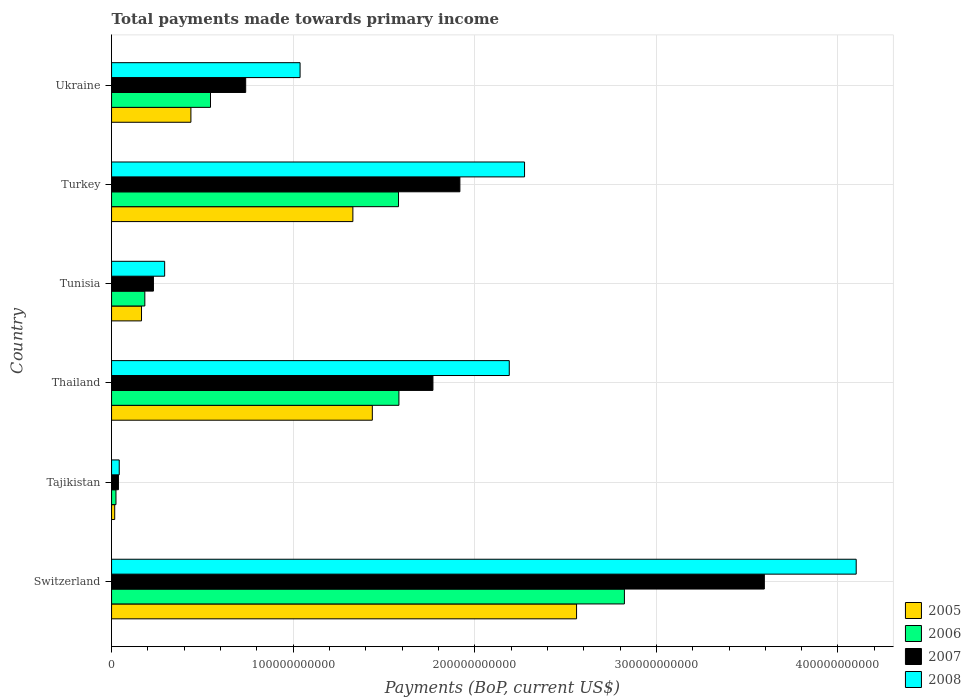How many groups of bars are there?
Offer a terse response. 6. Are the number of bars per tick equal to the number of legend labels?
Keep it short and to the point. Yes. How many bars are there on the 3rd tick from the top?
Provide a succinct answer. 4. What is the total payments made towards primary income in 2006 in Turkey?
Your answer should be very brief. 1.58e+11. Across all countries, what is the maximum total payments made towards primary income in 2005?
Your answer should be very brief. 2.56e+11. Across all countries, what is the minimum total payments made towards primary income in 2005?
Your response must be concise. 1.73e+09. In which country was the total payments made towards primary income in 2008 maximum?
Your answer should be very brief. Switzerland. In which country was the total payments made towards primary income in 2007 minimum?
Make the answer very short. Tajikistan. What is the total total payments made towards primary income in 2005 in the graph?
Make the answer very short. 5.94e+11. What is the difference between the total payments made towards primary income in 2008 in Tajikistan and that in Ukraine?
Your answer should be compact. -9.96e+1. What is the difference between the total payments made towards primary income in 2007 in Tunisia and the total payments made towards primary income in 2005 in Thailand?
Ensure brevity in your answer.  -1.21e+11. What is the average total payments made towards primary income in 2007 per country?
Ensure brevity in your answer.  1.38e+11. What is the difference between the total payments made towards primary income in 2006 and total payments made towards primary income in 2007 in Tunisia?
Your answer should be compact. -4.74e+09. In how many countries, is the total payments made towards primary income in 2006 greater than 360000000000 US$?
Give a very brief answer. 0. What is the ratio of the total payments made towards primary income in 2006 in Switzerland to that in Tajikistan?
Make the answer very short. 116.43. Is the total payments made towards primary income in 2008 in Switzerland less than that in Turkey?
Make the answer very short. No. Is the difference between the total payments made towards primary income in 2006 in Thailand and Turkey greater than the difference between the total payments made towards primary income in 2007 in Thailand and Turkey?
Provide a short and direct response. Yes. What is the difference between the highest and the second highest total payments made towards primary income in 2008?
Offer a very short reply. 1.83e+11. What is the difference between the highest and the lowest total payments made towards primary income in 2008?
Give a very brief answer. 4.06e+11. In how many countries, is the total payments made towards primary income in 2006 greater than the average total payments made towards primary income in 2006 taken over all countries?
Keep it short and to the point. 3. Is the sum of the total payments made towards primary income in 2005 in Tajikistan and Thailand greater than the maximum total payments made towards primary income in 2006 across all countries?
Provide a short and direct response. No. Is it the case that in every country, the sum of the total payments made towards primary income in 2006 and total payments made towards primary income in 2005 is greater than the sum of total payments made towards primary income in 2008 and total payments made towards primary income in 2007?
Your response must be concise. No. What does the 3rd bar from the bottom in Turkey represents?
Provide a short and direct response. 2007. How many countries are there in the graph?
Give a very brief answer. 6. What is the difference between two consecutive major ticks on the X-axis?
Keep it short and to the point. 1.00e+11. Does the graph contain any zero values?
Make the answer very short. No. Where does the legend appear in the graph?
Provide a short and direct response. Bottom right. How many legend labels are there?
Your answer should be compact. 4. How are the legend labels stacked?
Offer a very short reply. Vertical. What is the title of the graph?
Offer a very short reply. Total payments made towards primary income. What is the label or title of the X-axis?
Make the answer very short. Payments (BoP, current US$). What is the Payments (BoP, current US$) in 2005 in Switzerland?
Ensure brevity in your answer.  2.56e+11. What is the Payments (BoP, current US$) of 2006 in Switzerland?
Your response must be concise. 2.82e+11. What is the Payments (BoP, current US$) of 2007 in Switzerland?
Ensure brevity in your answer.  3.59e+11. What is the Payments (BoP, current US$) in 2008 in Switzerland?
Provide a short and direct response. 4.10e+11. What is the Payments (BoP, current US$) in 2005 in Tajikistan?
Offer a terse response. 1.73e+09. What is the Payments (BoP, current US$) in 2006 in Tajikistan?
Offer a terse response. 2.43e+09. What is the Payments (BoP, current US$) in 2007 in Tajikistan?
Your response must be concise. 3.78e+09. What is the Payments (BoP, current US$) of 2008 in Tajikistan?
Your answer should be very brief. 4.23e+09. What is the Payments (BoP, current US$) in 2005 in Thailand?
Give a very brief answer. 1.44e+11. What is the Payments (BoP, current US$) of 2006 in Thailand?
Make the answer very short. 1.58e+11. What is the Payments (BoP, current US$) in 2007 in Thailand?
Offer a very short reply. 1.77e+11. What is the Payments (BoP, current US$) in 2008 in Thailand?
Make the answer very short. 2.19e+11. What is the Payments (BoP, current US$) in 2005 in Tunisia?
Provide a short and direct response. 1.65e+1. What is the Payments (BoP, current US$) in 2006 in Tunisia?
Your answer should be compact. 1.83e+1. What is the Payments (BoP, current US$) of 2007 in Tunisia?
Offer a terse response. 2.31e+1. What is the Payments (BoP, current US$) in 2008 in Tunisia?
Your response must be concise. 2.92e+1. What is the Payments (BoP, current US$) in 2005 in Turkey?
Offer a very short reply. 1.33e+11. What is the Payments (BoP, current US$) in 2006 in Turkey?
Make the answer very short. 1.58e+11. What is the Payments (BoP, current US$) of 2007 in Turkey?
Your response must be concise. 1.92e+11. What is the Payments (BoP, current US$) of 2008 in Turkey?
Give a very brief answer. 2.27e+11. What is the Payments (BoP, current US$) of 2005 in Ukraine?
Your answer should be very brief. 4.37e+1. What is the Payments (BoP, current US$) of 2006 in Ukraine?
Offer a terse response. 5.45e+1. What is the Payments (BoP, current US$) in 2007 in Ukraine?
Give a very brief answer. 7.39e+1. What is the Payments (BoP, current US$) in 2008 in Ukraine?
Give a very brief answer. 1.04e+11. Across all countries, what is the maximum Payments (BoP, current US$) of 2005?
Provide a succinct answer. 2.56e+11. Across all countries, what is the maximum Payments (BoP, current US$) of 2006?
Your response must be concise. 2.82e+11. Across all countries, what is the maximum Payments (BoP, current US$) of 2007?
Offer a very short reply. 3.59e+11. Across all countries, what is the maximum Payments (BoP, current US$) in 2008?
Give a very brief answer. 4.10e+11. Across all countries, what is the minimum Payments (BoP, current US$) of 2005?
Ensure brevity in your answer.  1.73e+09. Across all countries, what is the minimum Payments (BoP, current US$) in 2006?
Ensure brevity in your answer.  2.43e+09. Across all countries, what is the minimum Payments (BoP, current US$) in 2007?
Provide a short and direct response. 3.78e+09. Across all countries, what is the minimum Payments (BoP, current US$) of 2008?
Make the answer very short. 4.23e+09. What is the total Payments (BoP, current US$) of 2005 in the graph?
Keep it short and to the point. 5.94e+11. What is the total Payments (BoP, current US$) in 2006 in the graph?
Give a very brief answer. 6.74e+11. What is the total Payments (BoP, current US$) in 2007 in the graph?
Your answer should be very brief. 8.29e+11. What is the total Payments (BoP, current US$) of 2008 in the graph?
Your answer should be compact. 9.94e+11. What is the difference between the Payments (BoP, current US$) of 2005 in Switzerland and that in Tajikistan?
Your answer should be very brief. 2.54e+11. What is the difference between the Payments (BoP, current US$) in 2006 in Switzerland and that in Tajikistan?
Make the answer very short. 2.80e+11. What is the difference between the Payments (BoP, current US$) of 2007 in Switzerland and that in Tajikistan?
Provide a short and direct response. 3.56e+11. What is the difference between the Payments (BoP, current US$) of 2008 in Switzerland and that in Tajikistan?
Provide a succinct answer. 4.06e+11. What is the difference between the Payments (BoP, current US$) of 2005 in Switzerland and that in Thailand?
Your answer should be very brief. 1.12e+11. What is the difference between the Payments (BoP, current US$) of 2006 in Switzerland and that in Thailand?
Keep it short and to the point. 1.24e+11. What is the difference between the Payments (BoP, current US$) of 2007 in Switzerland and that in Thailand?
Your answer should be compact. 1.82e+11. What is the difference between the Payments (BoP, current US$) in 2008 in Switzerland and that in Thailand?
Your answer should be very brief. 1.91e+11. What is the difference between the Payments (BoP, current US$) in 2005 in Switzerland and that in Tunisia?
Your answer should be very brief. 2.40e+11. What is the difference between the Payments (BoP, current US$) in 2006 in Switzerland and that in Tunisia?
Your response must be concise. 2.64e+11. What is the difference between the Payments (BoP, current US$) of 2007 in Switzerland and that in Tunisia?
Ensure brevity in your answer.  3.36e+11. What is the difference between the Payments (BoP, current US$) of 2008 in Switzerland and that in Tunisia?
Make the answer very short. 3.81e+11. What is the difference between the Payments (BoP, current US$) in 2005 in Switzerland and that in Turkey?
Ensure brevity in your answer.  1.23e+11. What is the difference between the Payments (BoP, current US$) in 2006 in Switzerland and that in Turkey?
Your response must be concise. 1.24e+11. What is the difference between the Payments (BoP, current US$) of 2007 in Switzerland and that in Turkey?
Give a very brief answer. 1.68e+11. What is the difference between the Payments (BoP, current US$) of 2008 in Switzerland and that in Turkey?
Offer a terse response. 1.83e+11. What is the difference between the Payments (BoP, current US$) in 2005 in Switzerland and that in Ukraine?
Ensure brevity in your answer.  2.12e+11. What is the difference between the Payments (BoP, current US$) in 2006 in Switzerland and that in Ukraine?
Ensure brevity in your answer.  2.28e+11. What is the difference between the Payments (BoP, current US$) of 2007 in Switzerland and that in Ukraine?
Offer a very short reply. 2.86e+11. What is the difference between the Payments (BoP, current US$) in 2008 in Switzerland and that in Ukraine?
Provide a succinct answer. 3.06e+11. What is the difference between the Payments (BoP, current US$) of 2005 in Tajikistan and that in Thailand?
Ensure brevity in your answer.  -1.42e+11. What is the difference between the Payments (BoP, current US$) in 2006 in Tajikistan and that in Thailand?
Give a very brief answer. -1.56e+11. What is the difference between the Payments (BoP, current US$) in 2007 in Tajikistan and that in Thailand?
Give a very brief answer. -1.73e+11. What is the difference between the Payments (BoP, current US$) in 2008 in Tajikistan and that in Thailand?
Give a very brief answer. -2.15e+11. What is the difference between the Payments (BoP, current US$) of 2005 in Tajikistan and that in Tunisia?
Your answer should be compact. -1.48e+1. What is the difference between the Payments (BoP, current US$) in 2006 in Tajikistan and that in Tunisia?
Offer a very short reply. -1.59e+1. What is the difference between the Payments (BoP, current US$) of 2007 in Tajikistan and that in Tunisia?
Keep it short and to the point. -1.93e+1. What is the difference between the Payments (BoP, current US$) of 2008 in Tajikistan and that in Tunisia?
Your answer should be compact. -2.50e+1. What is the difference between the Payments (BoP, current US$) in 2005 in Tajikistan and that in Turkey?
Ensure brevity in your answer.  -1.31e+11. What is the difference between the Payments (BoP, current US$) of 2006 in Tajikistan and that in Turkey?
Make the answer very short. -1.56e+11. What is the difference between the Payments (BoP, current US$) in 2007 in Tajikistan and that in Turkey?
Your answer should be compact. -1.88e+11. What is the difference between the Payments (BoP, current US$) in 2008 in Tajikistan and that in Turkey?
Offer a terse response. -2.23e+11. What is the difference between the Payments (BoP, current US$) of 2005 in Tajikistan and that in Ukraine?
Your response must be concise. -4.20e+1. What is the difference between the Payments (BoP, current US$) of 2006 in Tajikistan and that in Ukraine?
Your answer should be compact. -5.21e+1. What is the difference between the Payments (BoP, current US$) of 2007 in Tajikistan and that in Ukraine?
Provide a succinct answer. -7.01e+1. What is the difference between the Payments (BoP, current US$) of 2008 in Tajikistan and that in Ukraine?
Offer a terse response. -9.96e+1. What is the difference between the Payments (BoP, current US$) in 2005 in Thailand and that in Tunisia?
Keep it short and to the point. 1.27e+11. What is the difference between the Payments (BoP, current US$) of 2006 in Thailand and that in Tunisia?
Your answer should be compact. 1.40e+11. What is the difference between the Payments (BoP, current US$) of 2007 in Thailand and that in Tunisia?
Ensure brevity in your answer.  1.54e+11. What is the difference between the Payments (BoP, current US$) in 2008 in Thailand and that in Tunisia?
Offer a very short reply. 1.90e+11. What is the difference between the Payments (BoP, current US$) of 2005 in Thailand and that in Turkey?
Your response must be concise. 1.07e+1. What is the difference between the Payments (BoP, current US$) of 2006 in Thailand and that in Turkey?
Offer a terse response. 2.24e+08. What is the difference between the Payments (BoP, current US$) in 2007 in Thailand and that in Turkey?
Keep it short and to the point. -1.48e+1. What is the difference between the Payments (BoP, current US$) of 2008 in Thailand and that in Turkey?
Your response must be concise. -8.42e+09. What is the difference between the Payments (BoP, current US$) in 2005 in Thailand and that in Ukraine?
Your answer should be very brief. 9.99e+1. What is the difference between the Payments (BoP, current US$) in 2006 in Thailand and that in Ukraine?
Provide a short and direct response. 1.04e+11. What is the difference between the Payments (BoP, current US$) in 2007 in Thailand and that in Ukraine?
Offer a very short reply. 1.03e+11. What is the difference between the Payments (BoP, current US$) in 2008 in Thailand and that in Ukraine?
Your answer should be very brief. 1.15e+11. What is the difference between the Payments (BoP, current US$) in 2005 in Tunisia and that in Turkey?
Keep it short and to the point. -1.16e+11. What is the difference between the Payments (BoP, current US$) in 2006 in Tunisia and that in Turkey?
Provide a succinct answer. -1.40e+11. What is the difference between the Payments (BoP, current US$) in 2007 in Tunisia and that in Turkey?
Make the answer very short. -1.69e+11. What is the difference between the Payments (BoP, current US$) of 2008 in Tunisia and that in Turkey?
Provide a short and direct response. -1.98e+11. What is the difference between the Payments (BoP, current US$) of 2005 in Tunisia and that in Ukraine?
Ensure brevity in your answer.  -2.72e+1. What is the difference between the Payments (BoP, current US$) in 2006 in Tunisia and that in Ukraine?
Your answer should be very brief. -3.62e+1. What is the difference between the Payments (BoP, current US$) of 2007 in Tunisia and that in Ukraine?
Offer a very short reply. -5.08e+1. What is the difference between the Payments (BoP, current US$) of 2008 in Tunisia and that in Ukraine?
Offer a very short reply. -7.46e+1. What is the difference between the Payments (BoP, current US$) of 2005 in Turkey and that in Ukraine?
Provide a short and direct response. 8.92e+1. What is the difference between the Payments (BoP, current US$) of 2006 in Turkey and that in Ukraine?
Your answer should be compact. 1.04e+11. What is the difference between the Payments (BoP, current US$) in 2007 in Turkey and that in Ukraine?
Your response must be concise. 1.18e+11. What is the difference between the Payments (BoP, current US$) in 2008 in Turkey and that in Ukraine?
Give a very brief answer. 1.24e+11. What is the difference between the Payments (BoP, current US$) in 2005 in Switzerland and the Payments (BoP, current US$) in 2006 in Tajikistan?
Your answer should be compact. 2.54e+11. What is the difference between the Payments (BoP, current US$) of 2005 in Switzerland and the Payments (BoP, current US$) of 2007 in Tajikistan?
Your response must be concise. 2.52e+11. What is the difference between the Payments (BoP, current US$) in 2005 in Switzerland and the Payments (BoP, current US$) in 2008 in Tajikistan?
Provide a succinct answer. 2.52e+11. What is the difference between the Payments (BoP, current US$) of 2006 in Switzerland and the Payments (BoP, current US$) of 2007 in Tajikistan?
Your response must be concise. 2.79e+11. What is the difference between the Payments (BoP, current US$) of 2006 in Switzerland and the Payments (BoP, current US$) of 2008 in Tajikistan?
Keep it short and to the point. 2.78e+11. What is the difference between the Payments (BoP, current US$) in 2007 in Switzerland and the Payments (BoP, current US$) in 2008 in Tajikistan?
Your answer should be compact. 3.55e+11. What is the difference between the Payments (BoP, current US$) in 2005 in Switzerland and the Payments (BoP, current US$) in 2006 in Thailand?
Keep it short and to the point. 9.78e+1. What is the difference between the Payments (BoP, current US$) in 2005 in Switzerland and the Payments (BoP, current US$) in 2007 in Thailand?
Offer a very short reply. 7.91e+1. What is the difference between the Payments (BoP, current US$) in 2005 in Switzerland and the Payments (BoP, current US$) in 2008 in Thailand?
Provide a succinct answer. 3.71e+1. What is the difference between the Payments (BoP, current US$) in 2006 in Switzerland and the Payments (BoP, current US$) in 2007 in Thailand?
Offer a terse response. 1.05e+11. What is the difference between the Payments (BoP, current US$) of 2006 in Switzerland and the Payments (BoP, current US$) of 2008 in Thailand?
Ensure brevity in your answer.  6.34e+1. What is the difference between the Payments (BoP, current US$) in 2007 in Switzerland and the Payments (BoP, current US$) in 2008 in Thailand?
Ensure brevity in your answer.  1.40e+11. What is the difference between the Payments (BoP, current US$) of 2005 in Switzerland and the Payments (BoP, current US$) of 2006 in Tunisia?
Keep it short and to the point. 2.38e+11. What is the difference between the Payments (BoP, current US$) in 2005 in Switzerland and the Payments (BoP, current US$) in 2007 in Tunisia?
Make the answer very short. 2.33e+11. What is the difference between the Payments (BoP, current US$) of 2005 in Switzerland and the Payments (BoP, current US$) of 2008 in Tunisia?
Ensure brevity in your answer.  2.27e+11. What is the difference between the Payments (BoP, current US$) in 2006 in Switzerland and the Payments (BoP, current US$) in 2007 in Tunisia?
Keep it short and to the point. 2.59e+11. What is the difference between the Payments (BoP, current US$) in 2006 in Switzerland and the Payments (BoP, current US$) in 2008 in Tunisia?
Offer a terse response. 2.53e+11. What is the difference between the Payments (BoP, current US$) of 2007 in Switzerland and the Payments (BoP, current US$) of 2008 in Tunisia?
Your answer should be very brief. 3.30e+11. What is the difference between the Payments (BoP, current US$) of 2005 in Switzerland and the Payments (BoP, current US$) of 2006 in Turkey?
Keep it short and to the point. 9.80e+1. What is the difference between the Payments (BoP, current US$) of 2005 in Switzerland and the Payments (BoP, current US$) of 2007 in Turkey?
Make the answer very short. 6.42e+1. What is the difference between the Payments (BoP, current US$) of 2005 in Switzerland and the Payments (BoP, current US$) of 2008 in Turkey?
Your answer should be very brief. 2.86e+1. What is the difference between the Payments (BoP, current US$) in 2006 in Switzerland and the Payments (BoP, current US$) in 2007 in Turkey?
Offer a terse response. 9.06e+1. What is the difference between the Payments (BoP, current US$) in 2006 in Switzerland and the Payments (BoP, current US$) in 2008 in Turkey?
Your answer should be very brief. 5.50e+1. What is the difference between the Payments (BoP, current US$) of 2007 in Switzerland and the Payments (BoP, current US$) of 2008 in Turkey?
Your answer should be very brief. 1.32e+11. What is the difference between the Payments (BoP, current US$) in 2005 in Switzerland and the Payments (BoP, current US$) in 2006 in Ukraine?
Provide a succinct answer. 2.02e+11. What is the difference between the Payments (BoP, current US$) in 2005 in Switzerland and the Payments (BoP, current US$) in 2007 in Ukraine?
Provide a succinct answer. 1.82e+11. What is the difference between the Payments (BoP, current US$) in 2005 in Switzerland and the Payments (BoP, current US$) in 2008 in Ukraine?
Your response must be concise. 1.52e+11. What is the difference between the Payments (BoP, current US$) in 2006 in Switzerland and the Payments (BoP, current US$) in 2007 in Ukraine?
Give a very brief answer. 2.09e+11. What is the difference between the Payments (BoP, current US$) in 2006 in Switzerland and the Payments (BoP, current US$) in 2008 in Ukraine?
Give a very brief answer. 1.79e+11. What is the difference between the Payments (BoP, current US$) in 2007 in Switzerland and the Payments (BoP, current US$) in 2008 in Ukraine?
Give a very brief answer. 2.56e+11. What is the difference between the Payments (BoP, current US$) in 2005 in Tajikistan and the Payments (BoP, current US$) in 2006 in Thailand?
Provide a succinct answer. -1.57e+11. What is the difference between the Payments (BoP, current US$) in 2005 in Tajikistan and the Payments (BoP, current US$) in 2007 in Thailand?
Your answer should be very brief. -1.75e+11. What is the difference between the Payments (BoP, current US$) in 2005 in Tajikistan and the Payments (BoP, current US$) in 2008 in Thailand?
Offer a very short reply. -2.17e+11. What is the difference between the Payments (BoP, current US$) of 2006 in Tajikistan and the Payments (BoP, current US$) of 2007 in Thailand?
Provide a succinct answer. -1.75e+11. What is the difference between the Payments (BoP, current US$) in 2006 in Tajikistan and the Payments (BoP, current US$) in 2008 in Thailand?
Offer a terse response. -2.17e+11. What is the difference between the Payments (BoP, current US$) in 2007 in Tajikistan and the Payments (BoP, current US$) in 2008 in Thailand?
Offer a terse response. -2.15e+11. What is the difference between the Payments (BoP, current US$) in 2005 in Tajikistan and the Payments (BoP, current US$) in 2006 in Tunisia?
Make the answer very short. -1.66e+1. What is the difference between the Payments (BoP, current US$) in 2005 in Tajikistan and the Payments (BoP, current US$) in 2007 in Tunisia?
Offer a terse response. -2.13e+1. What is the difference between the Payments (BoP, current US$) of 2005 in Tajikistan and the Payments (BoP, current US$) of 2008 in Tunisia?
Offer a terse response. -2.75e+1. What is the difference between the Payments (BoP, current US$) of 2006 in Tajikistan and the Payments (BoP, current US$) of 2007 in Tunisia?
Offer a terse response. -2.06e+1. What is the difference between the Payments (BoP, current US$) of 2006 in Tajikistan and the Payments (BoP, current US$) of 2008 in Tunisia?
Provide a short and direct response. -2.68e+1. What is the difference between the Payments (BoP, current US$) in 2007 in Tajikistan and the Payments (BoP, current US$) in 2008 in Tunisia?
Your response must be concise. -2.55e+1. What is the difference between the Payments (BoP, current US$) in 2005 in Tajikistan and the Payments (BoP, current US$) in 2006 in Turkey?
Provide a succinct answer. -1.56e+11. What is the difference between the Payments (BoP, current US$) of 2005 in Tajikistan and the Payments (BoP, current US$) of 2007 in Turkey?
Your response must be concise. -1.90e+11. What is the difference between the Payments (BoP, current US$) in 2005 in Tajikistan and the Payments (BoP, current US$) in 2008 in Turkey?
Your response must be concise. -2.26e+11. What is the difference between the Payments (BoP, current US$) of 2006 in Tajikistan and the Payments (BoP, current US$) of 2007 in Turkey?
Make the answer very short. -1.89e+11. What is the difference between the Payments (BoP, current US$) of 2006 in Tajikistan and the Payments (BoP, current US$) of 2008 in Turkey?
Offer a terse response. -2.25e+11. What is the difference between the Payments (BoP, current US$) in 2007 in Tajikistan and the Payments (BoP, current US$) in 2008 in Turkey?
Keep it short and to the point. -2.24e+11. What is the difference between the Payments (BoP, current US$) in 2005 in Tajikistan and the Payments (BoP, current US$) in 2006 in Ukraine?
Your answer should be compact. -5.27e+1. What is the difference between the Payments (BoP, current US$) of 2005 in Tajikistan and the Payments (BoP, current US$) of 2007 in Ukraine?
Your answer should be very brief. -7.21e+1. What is the difference between the Payments (BoP, current US$) in 2005 in Tajikistan and the Payments (BoP, current US$) in 2008 in Ukraine?
Keep it short and to the point. -1.02e+11. What is the difference between the Payments (BoP, current US$) in 2006 in Tajikistan and the Payments (BoP, current US$) in 2007 in Ukraine?
Ensure brevity in your answer.  -7.14e+1. What is the difference between the Payments (BoP, current US$) of 2006 in Tajikistan and the Payments (BoP, current US$) of 2008 in Ukraine?
Provide a succinct answer. -1.01e+11. What is the difference between the Payments (BoP, current US$) of 2007 in Tajikistan and the Payments (BoP, current US$) of 2008 in Ukraine?
Provide a short and direct response. -1.00e+11. What is the difference between the Payments (BoP, current US$) of 2005 in Thailand and the Payments (BoP, current US$) of 2006 in Tunisia?
Your answer should be very brief. 1.25e+11. What is the difference between the Payments (BoP, current US$) of 2005 in Thailand and the Payments (BoP, current US$) of 2007 in Tunisia?
Make the answer very short. 1.21e+11. What is the difference between the Payments (BoP, current US$) of 2005 in Thailand and the Payments (BoP, current US$) of 2008 in Tunisia?
Keep it short and to the point. 1.14e+11. What is the difference between the Payments (BoP, current US$) of 2006 in Thailand and the Payments (BoP, current US$) of 2007 in Tunisia?
Offer a terse response. 1.35e+11. What is the difference between the Payments (BoP, current US$) of 2006 in Thailand and the Payments (BoP, current US$) of 2008 in Tunisia?
Your answer should be compact. 1.29e+11. What is the difference between the Payments (BoP, current US$) of 2007 in Thailand and the Payments (BoP, current US$) of 2008 in Tunisia?
Give a very brief answer. 1.48e+11. What is the difference between the Payments (BoP, current US$) of 2005 in Thailand and the Payments (BoP, current US$) of 2006 in Turkey?
Offer a terse response. -1.44e+1. What is the difference between the Payments (BoP, current US$) in 2005 in Thailand and the Payments (BoP, current US$) in 2007 in Turkey?
Provide a succinct answer. -4.82e+1. What is the difference between the Payments (BoP, current US$) of 2005 in Thailand and the Payments (BoP, current US$) of 2008 in Turkey?
Give a very brief answer. -8.38e+1. What is the difference between the Payments (BoP, current US$) of 2006 in Thailand and the Payments (BoP, current US$) of 2007 in Turkey?
Provide a short and direct response. -3.36e+1. What is the difference between the Payments (BoP, current US$) in 2006 in Thailand and the Payments (BoP, current US$) in 2008 in Turkey?
Provide a short and direct response. -6.92e+1. What is the difference between the Payments (BoP, current US$) of 2007 in Thailand and the Payments (BoP, current US$) of 2008 in Turkey?
Give a very brief answer. -5.04e+1. What is the difference between the Payments (BoP, current US$) in 2005 in Thailand and the Payments (BoP, current US$) in 2006 in Ukraine?
Provide a short and direct response. 8.91e+1. What is the difference between the Payments (BoP, current US$) in 2005 in Thailand and the Payments (BoP, current US$) in 2007 in Ukraine?
Provide a succinct answer. 6.97e+1. What is the difference between the Payments (BoP, current US$) in 2005 in Thailand and the Payments (BoP, current US$) in 2008 in Ukraine?
Ensure brevity in your answer.  3.98e+1. What is the difference between the Payments (BoP, current US$) of 2006 in Thailand and the Payments (BoP, current US$) of 2007 in Ukraine?
Offer a terse response. 8.44e+1. What is the difference between the Payments (BoP, current US$) in 2006 in Thailand and the Payments (BoP, current US$) in 2008 in Ukraine?
Your answer should be very brief. 5.44e+1. What is the difference between the Payments (BoP, current US$) of 2007 in Thailand and the Payments (BoP, current US$) of 2008 in Ukraine?
Keep it short and to the point. 7.32e+1. What is the difference between the Payments (BoP, current US$) in 2005 in Tunisia and the Payments (BoP, current US$) in 2006 in Turkey?
Provide a short and direct response. -1.42e+11. What is the difference between the Payments (BoP, current US$) in 2005 in Tunisia and the Payments (BoP, current US$) in 2007 in Turkey?
Offer a terse response. -1.75e+11. What is the difference between the Payments (BoP, current US$) of 2005 in Tunisia and the Payments (BoP, current US$) of 2008 in Turkey?
Offer a very short reply. -2.11e+11. What is the difference between the Payments (BoP, current US$) in 2006 in Tunisia and the Payments (BoP, current US$) in 2007 in Turkey?
Make the answer very short. -1.73e+11. What is the difference between the Payments (BoP, current US$) in 2006 in Tunisia and the Payments (BoP, current US$) in 2008 in Turkey?
Your answer should be very brief. -2.09e+11. What is the difference between the Payments (BoP, current US$) of 2007 in Tunisia and the Payments (BoP, current US$) of 2008 in Turkey?
Offer a very short reply. -2.04e+11. What is the difference between the Payments (BoP, current US$) in 2005 in Tunisia and the Payments (BoP, current US$) in 2006 in Ukraine?
Give a very brief answer. -3.80e+1. What is the difference between the Payments (BoP, current US$) of 2005 in Tunisia and the Payments (BoP, current US$) of 2007 in Ukraine?
Provide a short and direct response. -5.74e+1. What is the difference between the Payments (BoP, current US$) of 2005 in Tunisia and the Payments (BoP, current US$) of 2008 in Ukraine?
Your answer should be very brief. -8.73e+1. What is the difference between the Payments (BoP, current US$) of 2006 in Tunisia and the Payments (BoP, current US$) of 2007 in Ukraine?
Ensure brevity in your answer.  -5.55e+1. What is the difference between the Payments (BoP, current US$) of 2006 in Tunisia and the Payments (BoP, current US$) of 2008 in Ukraine?
Keep it short and to the point. -8.55e+1. What is the difference between the Payments (BoP, current US$) of 2007 in Tunisia and the Payments (BoP, current US$) of 2008 in Ukraine?
Ensure brevity in your answer.  -8.07e+1. What is the difference between the Payments (BoP, current US$) of 2005 in Turkey and the Payments (BoP, current US$) of 2006 in Ukraine?
Ensure brevity in your answer.  7.84e+1. What is the difference between the Payments (BoP, current US$) of 2005 in Turkey and the Payments (BoP, current US$) of 2007 in Ukraine?
Give a very brief answer. 5.90e+1. What is the difference between the Payments (BoP, current US$) of 2005 in Turkey and the Payments (BoP, current US$) of 2008 in Ukraine?
Make the answer very short. 2.91e+1. What is the difference between the Payments (BoP, current US$) of 2006 in Turkey and the Payments (BoP, current US$) of 2007 in Ukraine?
Give a very brief answer. 8.42e+1. What is the difference between the Payments (BoP, current US$) in 2006 in Turkey and the Payments (BoP, current US$) in 2008 in Ukraine?
Offer a very short reply. 5.42e+1. What is the difference between the Payments (BoP, current US$) of 2007 in Turkey and the Payments (BoP, current US$) of 2008 in Ukraine?
Offer a very short reply. 8.80e+1. What is the average Payments (BoP, current US$) in 2005 per country?
Your answer should be very brief. 9.91e+1. What is the average Payments (BoP, current US$) of 2006 per country?
Your answer should be very brief. 1.12e+11. What is the average Payments (BoP, current US$) of 2007 per country?
Keep it short and to the point. 1.38e+11. What is the average Payments (BoP, current US$) in 2008 per country?
Keep it short and to the point. 1.66e+11. What is the difference between the Payments (BoP, current US$) in 2005 and Payments (BoP, current US$) in 2006 in Switzerland?
Your answer should be very brief. -2.63e+1. What is the difference between the Payments (BoP, current US$) of 2005 and Payments (BoP, current US$) of 2007 in Switzerland?
Your answer should be very brief. -1.03e+11. What is the difference between the Payments (BoP, current US$) of 2005 and Payments (BoP, current US$) of 2008 in Switzerland?
Your response must be concise. -1.54e+11. What is the difference between the Payments (BoP, current US$) in 2006 and Payments (BoP, current US$) in 2007 in Switzerland?
Your answer should be very brief. -7.71e+1. What is the difference between the Payments (BoP, current US$) of 2006 and Payments (BoP, current US$) of 2008 in Switzerland?
Your answer should be very brief. -1.28e+11. What is the difference between the Payments (BoP, current US$) of 2007 and Payments (BoP, current US$) of 2008 in Switzerland?
Your answer should be very brief. -5.06e+1. What is the difference between the Payments (BoP, current US$) of 2005 and Payments (BoP, current US$) of 2006 in Tajikistan?
Your answer should be compact. -6.93e+08. What is the difference between the Payments (BoP, current US$) in 2005 and Payments (BoP, current US$) in 2007 in Tajikistan?
Offer a terse response. -2.05e+09. What is the difference between the Payments (BoP, current US$) in 2005 and Payments (BoP, current US$) in 2008 in Tajikistan?
Make the answer very short. -2.49e+09. What is the difference between the Payments (BoP, current US$) in 2006 and Payments (BoP, current US$) in 2007 in Tajikistan?
Give a very brief answer. -1.35e+09. What is the difference between the Payments (BoP, current US$) in 2006 and Payments (BoP, current US$) in 2008 in Tajikistan?
Your answer should be very brief. -1.80e+09. What is the difference between the Payments (BoP, current US$) of 2007 and Payments (BoP, current US$) of 2008 in Tajikistan?
Offer a terse response. -4.47e+08. What is the difference between the Payments (BoP, current US$) of 2005 and Payments (BoP, current US$) of 2006 in Thailand?
Provide a short and direct response. -1.46e+1. What is the difference between the Payments (BoP, current US$) in 2005 and Payments (BoP, current US$) in 2007 in Thailand?
Your answer should be very brief. -3.34e+1. What is the difference between the Payments (BoP, current US$) of 2005 and Payments (BoP, current US$) of 2008 in Thailand?
Your answer should be very brief. -7.54e+1. What is the difference between the Payments (BoP, current US$) in 2006 and Payments (BoP, current US$) in 2007 in Thailand?
Your answer should be very brief. -1.87e+1. What is the difference between the Payments (BoP, current US$) in 2006 and Payments (BoP, current US$) in 2008 in Thailand?
Ensure brevity in your answer.  -6.08e+1. What is the difference between the Payments (BoP, current US$) in 2007 and Payments (BoP, current US$) in 2008 in Thailand?
Your response must be concise. -4.20e+1. What is the difference between the Payments (BoP, current US$) of 2005 and Payments (BoP, current US$) of 2006 in Tunisia?
Give a very brief answer. -1.82e+09. What is the difference between the Payments (BoP, current US$) of 2005 and Payments (BoP, current US$) of 2007 in Tunisia?
Make the answer very short. -6.57e+09. What is the difference between the Payments (BoP, current US$) of 2005 and Payments (BoP, current US$) of 2008 in Tunisia?
Offer a very short reply. -1.27e+1. What is the difference between the Payments (BoP, current US$) in 2006 and Payments (BoP, current US$) in 2007 in Tunisia?
Give a very brief answer. -4.74e+09. What is the difference between the Payments (BoP, current US$) of 2006 and Payments (BoP, current US$) of 2008 in Tunisia?
Provide a succinct answer. -1.09e+1. What is the difference between the Payments (BoP, current US$) in 2007 and Payments (BoP, current US$) in 2008 in Tunisia?
Provide a succinct answer. -6.17e+09. What is the difference between the Payments (BoP, current US$) in 2005 and Payments (BoP, current US$) in 2006 in Turkey?
Your response must be concise. -2.51e+1. What is the difference between the Payments (BoP, current US$) in 2005 and Payments (BoP, current US$) in 2007 in Turkey?
Make the answer very short. -5.89e+1. What is the difference between the Payments (BoP, current US$) in 2005 and Payments (BoP, current US$) in 2008 in Turkey?
Keep it short and to the point. -9.45e+1. What is the difference between the Payments (BoP, current US$) in 2006 and Payments (BoP, current US$) in 2007 in Turkey?
Provide a succinct answer. -3.38e+1. What is the difference between the Payments (BoP, current US$) in 2006 and Payments (BoP, current US$) in 2008 in Turkey?
Your answer should be very brief. -6.94e+1. What is the difference between the Payments (BoP, current US$) in 2007 and Payments (BoP, current US$) in 2008 in Turkey?
Keep it short and to the point. -3.56e+1. What is the difference between the Payments (BoP, current US$) in 2005 and Payments (BoP, current US$) in 2006 in Ukraine?
Keep it short and to the point. -1.08e+1. What is the difference between the Payments (BoP, current US$) in 2005 and Payments (BoP, current US$) in 2007 in Ukraine?
Your response must be concise. -3.02e+1. What is the difference between the Payments (BoP, current US$) in 2005 and Payments (BoP, current US$) in 2008 in Ukraine?
Your answer should be compact. -6.01e+1. What is the difference between the Payments (BoP, current US$) of 2006 and Payments (BoP, current US$) of 2007 in Ukraine?
Offer a very short reply. -1.94e+1. What is the difference between the Payments (BoP, current US$) in 2006 and Payments (BoP, current US$) in 2008 in Ukraine?
Your response must be concise. -4.93e+1. What is the difference between the Payments (BoP, current US$) of 2007 and Payments (BoP, current US$) of 2008 in Ukraine?
Provide a succinct answer. -2.99e+1. What is the ratio of the Payments (BoP, current US$) of 2005 in Switzerland to that in Tajikistan?
Keep it short and to the point. 147.77. What is the ratio of the Payments (BoP, current US$) in 2006 in Switzerland to that in Tajikistan?
Your answer should be compact. 116.43. What is the ratio of the Payments (BoP, current US$) of 2007 in Switzerland to that in Tajikistan?
Your response must be concise. 95.09. What is the ratio of the Payments (BoP, current US$) in 2008 in Switzerland to that in Tajikistan?
Ensure brevity in your answer.  97. What is the ratio of the Payments (BoP, current US$) in 2005 in Switzerland to that in Thailand?
Ensure brevity in your answer.  1.78. What is the ratio of the Payments (BoP, current US$) of 2006 in Switzerland to that in Thailand?
Ensure brevity in your answer.  1.78. What is the ratio of the Payments (BoP, current US$) of 2007 in Switzerland to that in Thailand?
Your answer should be compact. 2.03. What is the ratio of the Payments (BoP, current US$) of 2008 in Switzerland to that in Thailand?
Ensure brevity in your answer.  1.87. What is the ratio of the Payments (BoP, current US$) of 2005 in Switzerland to that in Tunisia?
Your response must be concise. 15.52. What is the ratio of the Payments (BoP, current US$) of 2006 in Switzerland to that in Tunisia?
Provide a succinct answer. 15.41. What is the ratio of the Payments (BoP, current US$) of 2007 in Switzerland to that in Tunisia?
Your answer should be very brief. 15.59. What is the ratio of the Payments (BoP, current US$) in 2008 in Switzerland to that in Tunisia?
Provide a short and direct response. 14.03. What is the ratio of the Payments (BoP, current US$) of 2005 in Switzerland to that in Turkey?
Provide a short and direct response. 1.93. What is the ratio of the Payments (BoP, current US$) in 2006 in Switzerland to that in Turkey?
Offer a terse response. 1.79. What is the ratio of the Payments (BoP, current US$) of 2007 in Switzerland to that in Turkey?
Your answer should be compact. 1.87. What is the ratio of the Payments (BoP, current US$) in 2008 in Switzerland to that in Turkey?
Keep it short and to the point. 1.8. What is the ratio of the Payments (BoP, current US$) of 2005 in Switzerland to that in Ukraine?
Your answer should be compact. 5.86. What is the ratio of the Payments (BoP, current US$) of 2006 in Switzerland to that in Ukraine?
Your answer should be very brief. 5.18. What is the ratio of the Payments (BoP, current US$) of 2007 in Switzerland to that in Ukraine?
Give a very brief answer. 4.87. What is the ratio of the Payments (BoP, current US$) of 2008 in Switzerland to that in Ukraine?
Give a very brief answer. 3.95. What is the ratio of the Payments (BoP, current US$) of 2005 in Tajikistan to that in Thailand?
Provide a short and direct response. 0.01. What is the ratio of the Payments (BoP, current US$) in 2006 in Tajikistan to that in Thailand?
Your response must be concise. 0.02. What is the ratio of the Payments (BoP, current US$) of 2007 in Tajikistan to that in Thailand?
Your answer should be very brief. 0.02. What is the ratio of the Payments (BoP, current US$) of 2008 in Tajikistan to that in Thailand?
Offer a very short reply. 0.02. What is the ratio of the Payments (BoP, current US$) of 2005 in Tajikistan to that in Tunisia?
Your response must be concise. 0.1. What is the ratio of the Payments (BoP, current US$) of 2006 in Tajikistan to that in Tunisia?
Your answer should be compact. 0.13. What is the ratio of the Payments (BoP, current US$) in 2007 in Tajikistan to that in Tunisia?
Provide a succinct answer. 0.16. What is the ratio of the Payments (BoP, current US$) of 2008 in Tajikistan to that in Tunisia?
Keep it short and to the point. 0.14. What is the ratio of the Payments (BoP, current US$) of 2005 in Tajikistan to that in Turkey?
Your answer should be very brief. 0.01. What is the ratio of the Payments (BoP, current US$) in 2006 in Tajikistan to that in Turkey?
Keep it short and to the point. 0.02. What is the ratio of the Payments (BoP, current US$) of 2007 in Tajikistan to that in Turkey?
Provide a short and direct response. 0.02. What is the ratio of the Payments (BoP, current US$) in 2008 in Tajikistan to that in Turkey?
Your response must be concise. 0.02. What is the ratio of the Payments (BoP, current US$) in 2005 in Tajikistan to that in Ukraine?
Your response must be concise. 0.04. What is the ratio of the Payments (BoP, current US$) of 2006 in Tajikistan to that in Ukraine?
Provide a succinct answer. 0.04. What is the ratio of the Payments (BoP, current US$) of 2007 in Tajikistan to that in Ukraine?
Your answer should be compact. 0.05. What is the ratio of the Payments (BoP, current US$) of 2008 in Tajikistan to that in Ukraine?
Make the answer very short. 0.04. What is the ratio of the Payments (BoP, current US$) of 2005 in Thailand to that in Tunisia?
Offer a terse response. 8.7. What is the ratio of the Payments (BoP, current US$) of 2006 in Thailand to that in Tunisia?
Your response must be concise. 8.64. What is the ratio of the Payments (BoP, current US$) in 2007 in Thailand to that in Tunisia?
Offer a very short reply. 7.67. What is the ratio of the Payments (BoP, current US$) in 2008 in Thailand to that in Tunisia?
Your response must be concise. 7.49. What is the ratio of the Payments (BoP, current US$) of 2005 in Thailand to that in Turkey?
Your response must be concise. 1.08. What is the ratio of the Payments (BoP, current US$) of 2007 in Thailand to that in Turkey?
Give a very brief answer. 0.92. What is the ratio of the Payments (BoP, current US$) in 2008 in Thailand to that in Turkey?
Your response must be concise. 0.96. What is the ratio of the Payments (BoP, current US$) in 2005 in Thailand to that in Ukraine?
Offer a terse response. 3.29. What is the ratio of the Payments (BoP, current US$) in 2006 in Thailand to that in Ukraine?
Ensure brevity in your answer.  2.9. What is the ratio of the Payments (BoP, current US$) in 2007 in Thailand to that in Ukraine?
Offer a terse response. 2.4. What is the ratio of the Payments (BoP, current US$) of 2008 in Thailand to that in Ukraine?
Offer a very short reply. 2.11. What is the ratio of the Payments (BoP, current US$) of 2005 in Tunisia to that in Turkey?
Ensure brevity in your answer.  0.12. What is the ratio of the Payments (BoP, current US$) in 2006 in Tunisia to that in Turkey?
Provide a short and direct response. 0.12. What is the ratio of the Payments (BoP, current US$) of 2007 in Tunisia to that in Turkey?
Your answer should be very brief. 0.12. What is the ratio of the Payments (BoP, current US$) in 2008 in Tunisia to that in Turkey?
Ensure brevity in your answer.  0.13. What is the ratio of the Payments (BoP, current US$) in 2005 in Tunisia to that in Ukraine?
Keep it short and to the point. 0.38. What is the ratio of the Payments (BoP, current US$) in 2006 in Tunisia to that in Ukraine?
Make the answer very short. 0.34. What is the ratio of the Payments (BoP, current US$) of 2007 in Tunisia to that in Ukraine?
Ensure brevity in your answer.  0.31. What is the ratio of the Payments (BoP, current US$) in 2008 in Tunisia to that in Ukraine?
Offer a very short reply. 0.28. What is the ratio of the Payments (BoP, current US$) in 2005 in Turkey to that in Ukraine?
Offer a terse response. 3.04. What is the ratio of the Payments (BoP, current US$) in 2006 in Turkey to that in Ukraine?
Provide a short and direct response. 2.9. What is the ratio of the Payments (BoP, current US$) in 2007 in Turkey to that in Ukraine?
Provide a short and direct response. 2.6. What is the ratio of the Payments (BoP, current US$) of 2008 in Turkey to that in Ukraine?
Provide a short and direct response. 2.19. What is the difference between the highest and the second highest Payments (BoP, current US$) of 2005?
Offer a terse response. 1.12e+11. What is the difference between the highest and the second highest Payments (BoP, current US$) of 2006?
Provide a short and direct response. 1.24e+11. What is the difference between the highest and the second highest Payments (BoP, current US$) in 2007?
Provide a succinct answer. 1.68e+11. What is the difference between the highest and the second highest Payments (BoP, current US$) of 2008?
Ensure brevity in your answer.  1.83e+11. What is the difference between the highest and the lowest Payments (BoP, current US$) of 2005?
Ensure brevity in your answer.  2.54e+11. What is the difference between the highest and the lowest Payments (BoP, current US$) of 2006?
Offer a terse response. 2.80e+11. What is the difference between the highest and the lowest Payments (BoP, current US$) in 2007?
Your answer should be very brief. 3.56e+11. What is the difference between the highest and the lowest Payments (BoP, current US$) of 2008?
Make the answer very short. 4.06e+11. 